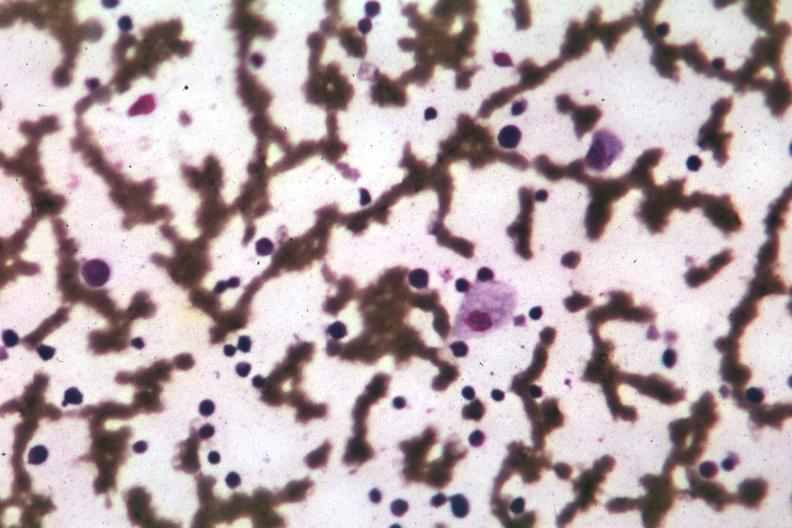what does this image show?
Answer the question using a single word or phrase. Wrights single cell easily seen 